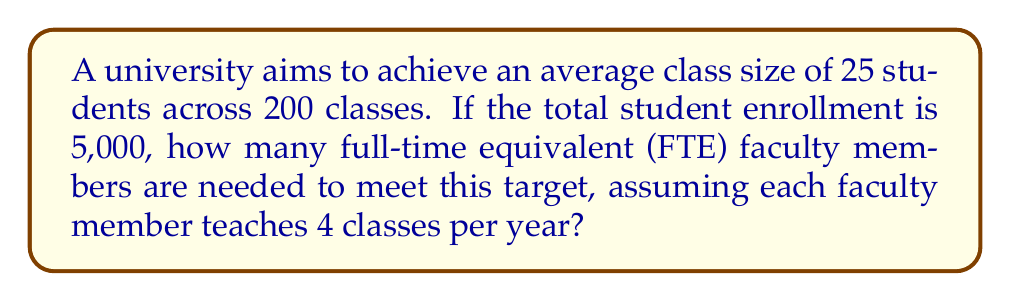Show me your answer to this math problem. Let's approach this step-by-step:

1) First, calculate the total number of student seats needed:
   Number of classes × Target class size = Total student seats
   $$ 200 \times 25 = 5,000 \text{ student seats} $$

2) This matches the total student enrollment, which is a good check.

3) Now, calculate the total number of classes that need to be taught:
   $$ 200 \text{ classes} $$

4) Each faculty member teaches 4 classes per year, so to find the number of faculty needed:
   $$ \text{Number of faculty} = \frac{\text{Total classes}}{\text{Classes per faculty}} $$

5) Substituting the values:
   $$ \text{Number of faculty} = \frac{200}{4} = 50 $$

Therefore, the university needs 50 FTE faculty members to achieve the target class size.

6) As a final check, we can calculate the overall faculty-to-student ratio:
   $$ \text{Faculty-to-student ratio} = \frac{5,000 \text{ students}}{50 \text{ faculty}} = 100:1 $$

This ratio can be useful for the institution to compare with competitors or industry standards.
Answer: 50 FTE faculty members 